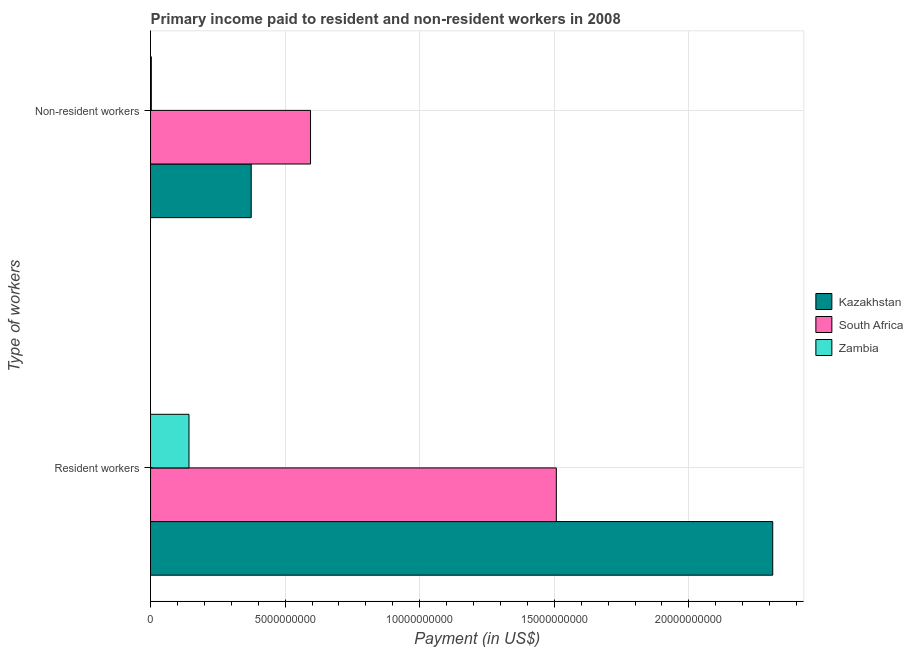How many different coloured bars are there?
Keep it short and to the point. 3. How many groups of bars are there?
Provide a short and direct response. 2. Are the number of bars per tick equal to the number of legend labels?
Offer a terse response. Yes. How many bars are there on the 2nd tick from the top?
Provide a succinct answer. 3. How many bars are there on the 1st tick from the bottom?
Your answer should be very brief. 3. What is the label of the 1st group of bars from the top?
Provide a short and direct response. Non-resident workers. What is the payment made to resident workers in Zambia?
Your answer should be compact. 1.43e+09. Across all countries, what is the maximum payment made to non-resident workers?
Give a very brief answer. 5.94e+09. Across all countries, what is the minimum payment made to non-resident workers?
Offer a terse response. 2.95e+07. In which country was the payment made to resident workers maximum?
Give a very brief answer. Kazakhstan. In which country was the payment made to non-resident workers minimum?
Provide a short and direct response. Zambia. What is the total payment made to resident workers in the graph?
Offer a terse response. 3.96e+1. What is the difference between the payment made to resident workers in South Africa and that in Kazakhstan?
Keep it short and to the point. -8.04e+09. What is the difference between the payment made to resident workers in South Africa and the payment made to non-resident workers in Zambia?
Give a very brief answer. 1.50e+1. What is the average payment made to resident workers per country?
Make the answer very short. 1.32e+1. What is the difference between the payment made to non-resident workers and payment made to resident workers in South Africa?
Offer a very short reply. -9.13e+09. In how many countries, is the payment made to non-resident workers greater than 11000000000 US$?
Your response must be concise. 0. What is the ratio of the payment made to resident workers in Kazakhstan to that in Zambia?
Keep it short and to the point. 16.18. Is the payment made to resident workers in Kazakhstan less than that in South Africa?
Your response must be concise. No. In how many countries, is the payment made to resident workers greater than the average payment made to resident workers taken over all countries?
Your answer should be compact. 2. What does the 3rd bar from the top in Resident workers represents?
Provide a succinct answer. Kazakhstan. What does the 1st bar from the bottom in Non-resident workers represents?
Offer a terse response. Kazakhstan. Are all the bars in the graph horizontal?
Ensure brevity in your answer.  Yes. How many countries are there in the graph?
Offer a terse response. 3. What is the difference between two consecutive major ticks on the X-axis?
Offer a very short reply. 5.00e+09. Does the graph contain grids?
Your answer should be compact. Yes. Where does the legend appear in the graph?
Your answer should be very brief. Center right. How many legend labels are there?
Your response must be concise. 3. How are the legend labels stacked?
Provide a succinct answer. Vertical. What is the title of the graph?
Your response must be concise. Primary income paid to resident and non-resident workers in 2008. Does "Ghana" appear as one of the legend labels in the graph?
Ensure brevity in your answer.  No. What is the label or title of the X-axis?
Your answer should be very brief. Payment (in US$). What is the label or title of the Y-axis?
Provide a succinct answer. Type of workers. What is the Payment (in US$) of Kazakhstan in Resident workers?
Make the answer very short. 2.31e+1. What is the Payment (in US$) of South Africa in Resident workers?
Your answer should be very brief. 1.51e+1. What is the Payment (in US$) of Zambia in Resident workers?
Provide a succinct answer. 1.43e+09. What is the Payment (in US$) of Kazakhstan in Non-resident workers?
Your answer should be compact. 3.74e+09. What is the Payment (in US$) in South Africa in Non-resident workers?
Offer a very short reply. 5.94e+09. What is the Payment (in US$) of Zambia in Non-resident workers?
Offer a terse response. 2.95e+07. Across all Type of workers, what is the maximum Payment (in US$) of Kazakhstan?
Your answer should be very brief. 2.31e+1. Across all Type of workers, what is the maximum Payment (in US$) of South Africa?
Keep it short and to the point. 1.51e+1. Across all Type of workers, what is the maximum Payment (in US$) of Zambia?
Your response must be concise. 1.43e+09. Across all Type of workers, what is the minimum Payment (in US$) in Kazakhstan?
Your response must be concise. 3.74e+09. Across all Type of workers, what is the minimum Payment (in US$) of South Africa?
Offer a terse response. 5.94e+09. Across all Type of workers, what is the minimum Payment (in US$) of Zambia?
Ensure brevity in your answer.  2.95e+07. What is the total Payment (in US$) in Kazakhstan in the graph?
Your answer should be compact. 2.69e+1. What is the total Payment (in US$) in South Africa in the graph?
Give a very brief answer. 2.10e+1. What is the total Payment (in US$) in Zambia in the graph?
Provide a short and direct response. 1.46e+09. What is the difference between the Payment (in US$) of Kazakhstan in Resident workers and that in Non-resident workers?
Offer a very short reply. 1.94e+1. What is the difference between the Payment (in US$) of South Africa in Resident workers and that in Non-resident workers?
Provide a succinct answer. 9.13e+09. What is the difference between the Payment (in US$) of Zambia in Resident workers and that in Non-resident workers?
Ensure brevity in your answer.  1.40e+09. What is the difference between the Payment (in US$) in Kazakhstan in Resident workers and the Payment (in US$) in South Africa in Non-resident workers?
Make the answer very short. 1.72e+1. What is the difference between the Payment (in US$) of Kazakhstan in Resident workers and the Payment (in US$) of Zambia in Non-resident workers?
Make the answer very short. 2.31e+1. What is the difference between the Payment (in US$) in South Africa in Resident workers and the Payment (in US$) in Zambia in Non-resident workers?
Make the answer very short. 1.50e+1. What is the average Payment (in US$) of Kazakhstan per Type of workers?
Your response must be concise. 1.34e+1. What is the average Payment (in US$) in South Africa per Type of workers?
Give a very brief answer. 1.05e+1. What is the average Payment (in US$) of Zambia per Type of workers?
Offer a very short reply. 7.29e+08. What is the difference between the Payment (in US$) of Kazakhstan and Payment (in US$) of South Africa in Resident workers?
Your answer should be compact. 8.04e+09. What is the difference between the Payment (in US$) of Kazakhstan and Payment (in US$) of Zambia in Resident workers?
Make the answer very short. 2.17e+1. What is the difference between the Payment (in US$) of South Africa and Payment (in US$) of Zambia in Resident workers?
Provide a succinct answer. 1.36e+1. What is the difference between the Payment (in US$) in Kazakhstan and Payment (in US$) in South Africa in Non-resident workers?
Your response must be concise. -2.20e+09. What is the difference between the Payment (in US$) of Kazakhstan and Payment (in US$) of Zambia in Non-resident workers?
Your answer should be very brief. 3.71e+09. What is the difference between the Payment (in US$) of South Africa and Payment (in US$) of Zambia in Non-resident workers?
Your response must be concise. 5.91e+09. What is the ratio of the Payment (in US$) in Kazakhstan in Resident workers to that in Non-resident workers?
Give a very brief answer. 6.18. What is the ratio of the Payment (in US$) of South Africa in Resident workers to that in Non-resident workers?
Your response must be concise. 2.54. What is the ratio of the Payment (in US$) in Zambia in Resident workers to that in Non-resident workers?
Make the answer very short. 48.38. What is the difference between the highest and the second highest Payment (in US$) of Kazakhstan?
Offer a very short reply. 1.94e+1. What is the difference between the highest and the second highest Payment (in US$) of South Africa?
Your response must be concise. 9.13e+09. What is the difference between the highest and the second highest Payment (in US$) of Zambia?
Offer a terse response. 1.40e+09. What is the difference between the highest and the lowest Payment (in US$) in Kazakhstan?
Keep it short and to the point. 1.94e+1. What is the difference between the highest and the lowest Payment (in US$) in South Africa?
Make the answer very short. 9.13e+09. What is the difference between the highest and the lowest Payment (in US$) of Zambia?
Your answer should be compact. 1.40e+09. 